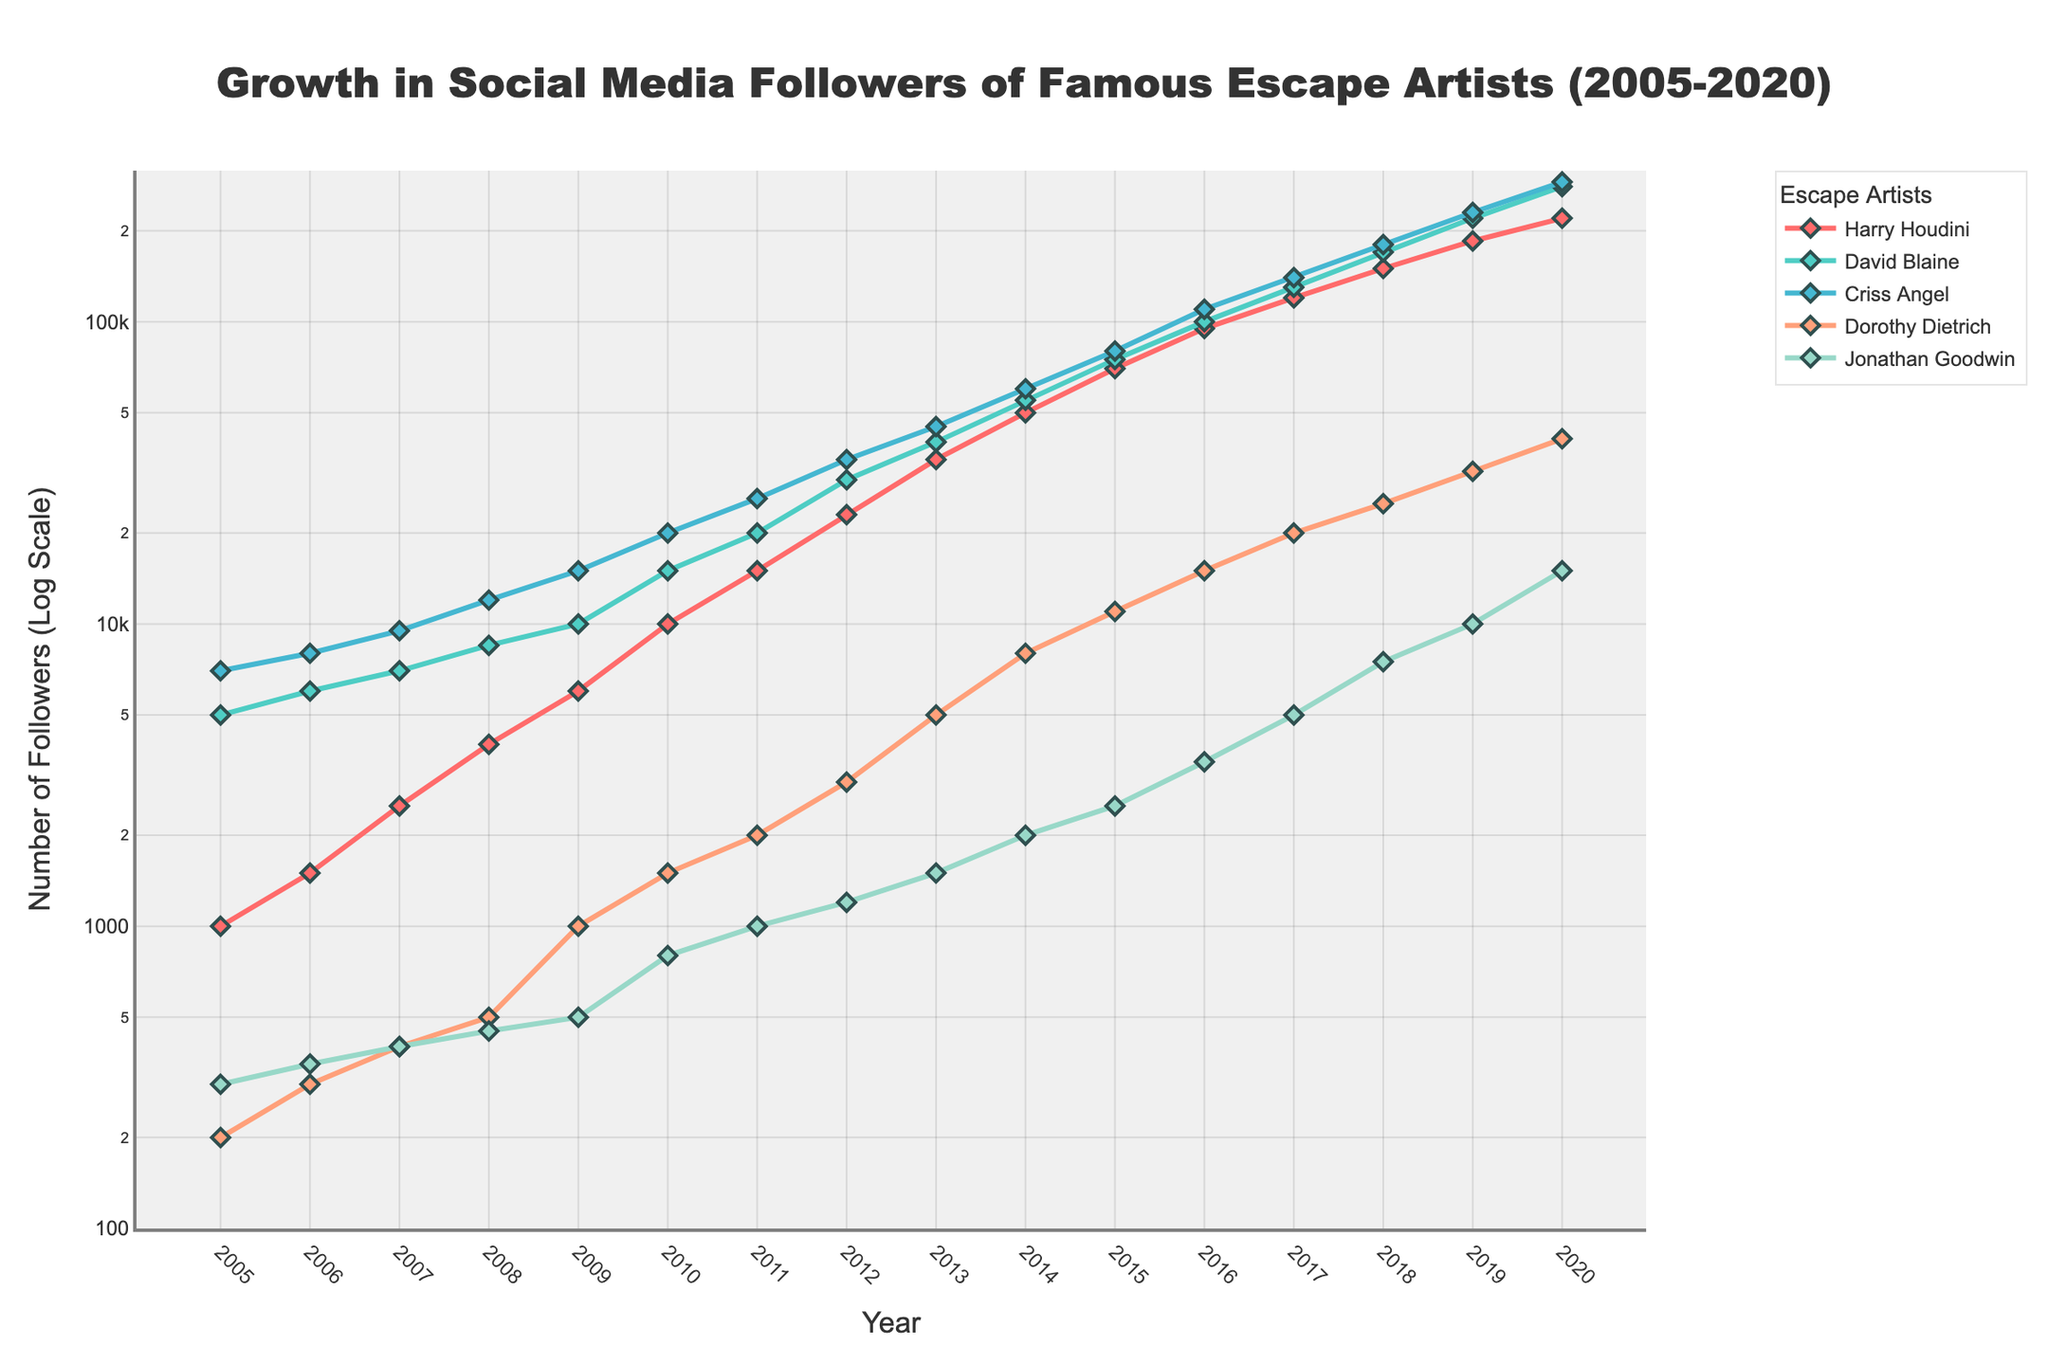What is the title of the plot? The title of the plot is usually placed at the top center and provides a summary of what the figure is about. In this case, it shows the overall theme and timeframe of the data.
Answer: Growth in Social Media Followers of Famous Escape Artists (2005-2020) Which escape artist had the highest number of social media followers in 2020? By looking at the data points for the year 2020 along the respective artist lines, we identify the highest value among all escape artists. The highest point in 2020 is observed for Criss Angel.
Answer: Criss Angel How many escape artists are compared in the plot? The legend on the right side of the plot lists the names/colors of the escape artists being compared. Counting these names directly tells us the number of escape artists.
Answer: 5 What is the approximate number of followers for David Blaine in 2015? Locate the data point for David Blaine in the year 2015 by following the corresponding line and marker. The value is directly reflected by the y-axis at that point.
Answer: 75,000 Between which two consecutive years did Harry Houdini see the highest growth in followers? By examining the steepest slope on Harry Houdini's line, we determine the highest growth. The steepest slope appears between 2016 and 2017.
Answer: 2016-2017 What is the average number of followers for Dorothy Dietrich across all years shown? Summing up the values for Dorothy Dietrich and then dividing by the total number of years, we find the average: (200 + 300 + 400 + 500 + 1000 + 1500 + 2000 + 3000 + 5000 + 8000 + 11000 + 15000 + 20000 + 25000 + 32000 + 41000) / 16 = 93875/16
Answer: 5,860 Which artist had the least growth in followers from 2005 to 2020? By comparing the overall increase from 2005 to 2020 for each artist, the smallest increment is noted for Jonathan Goodwin (300 to 15000).
Answer: Jonathan Goodwin What was the approximate growth rate (as a factor) for Criss Angel between 2005 and 2020? The growth factor is calculated by dividing the final number of followers by the initial number: 290000 / 7000 = ~41.43
Answer: ~41.43 How many data points are plotted for each artist? Since data is provided for each year from 2005 to 2020, and this results in one data point per year for each artist, counting years gives the number of data points.
Answer: 16 Between which years did David Blaine transition from having fewer followers than Harry Houdini to having more followers? Comparing the trajectories of their growth lines, David Blaine surpasses Harry Houdini between 2005 and 2013 and then 2020. The exact intersection appears between 2017 and 2018 and 2019-2020.
Answer: 2017-2018 and 2019-2020 